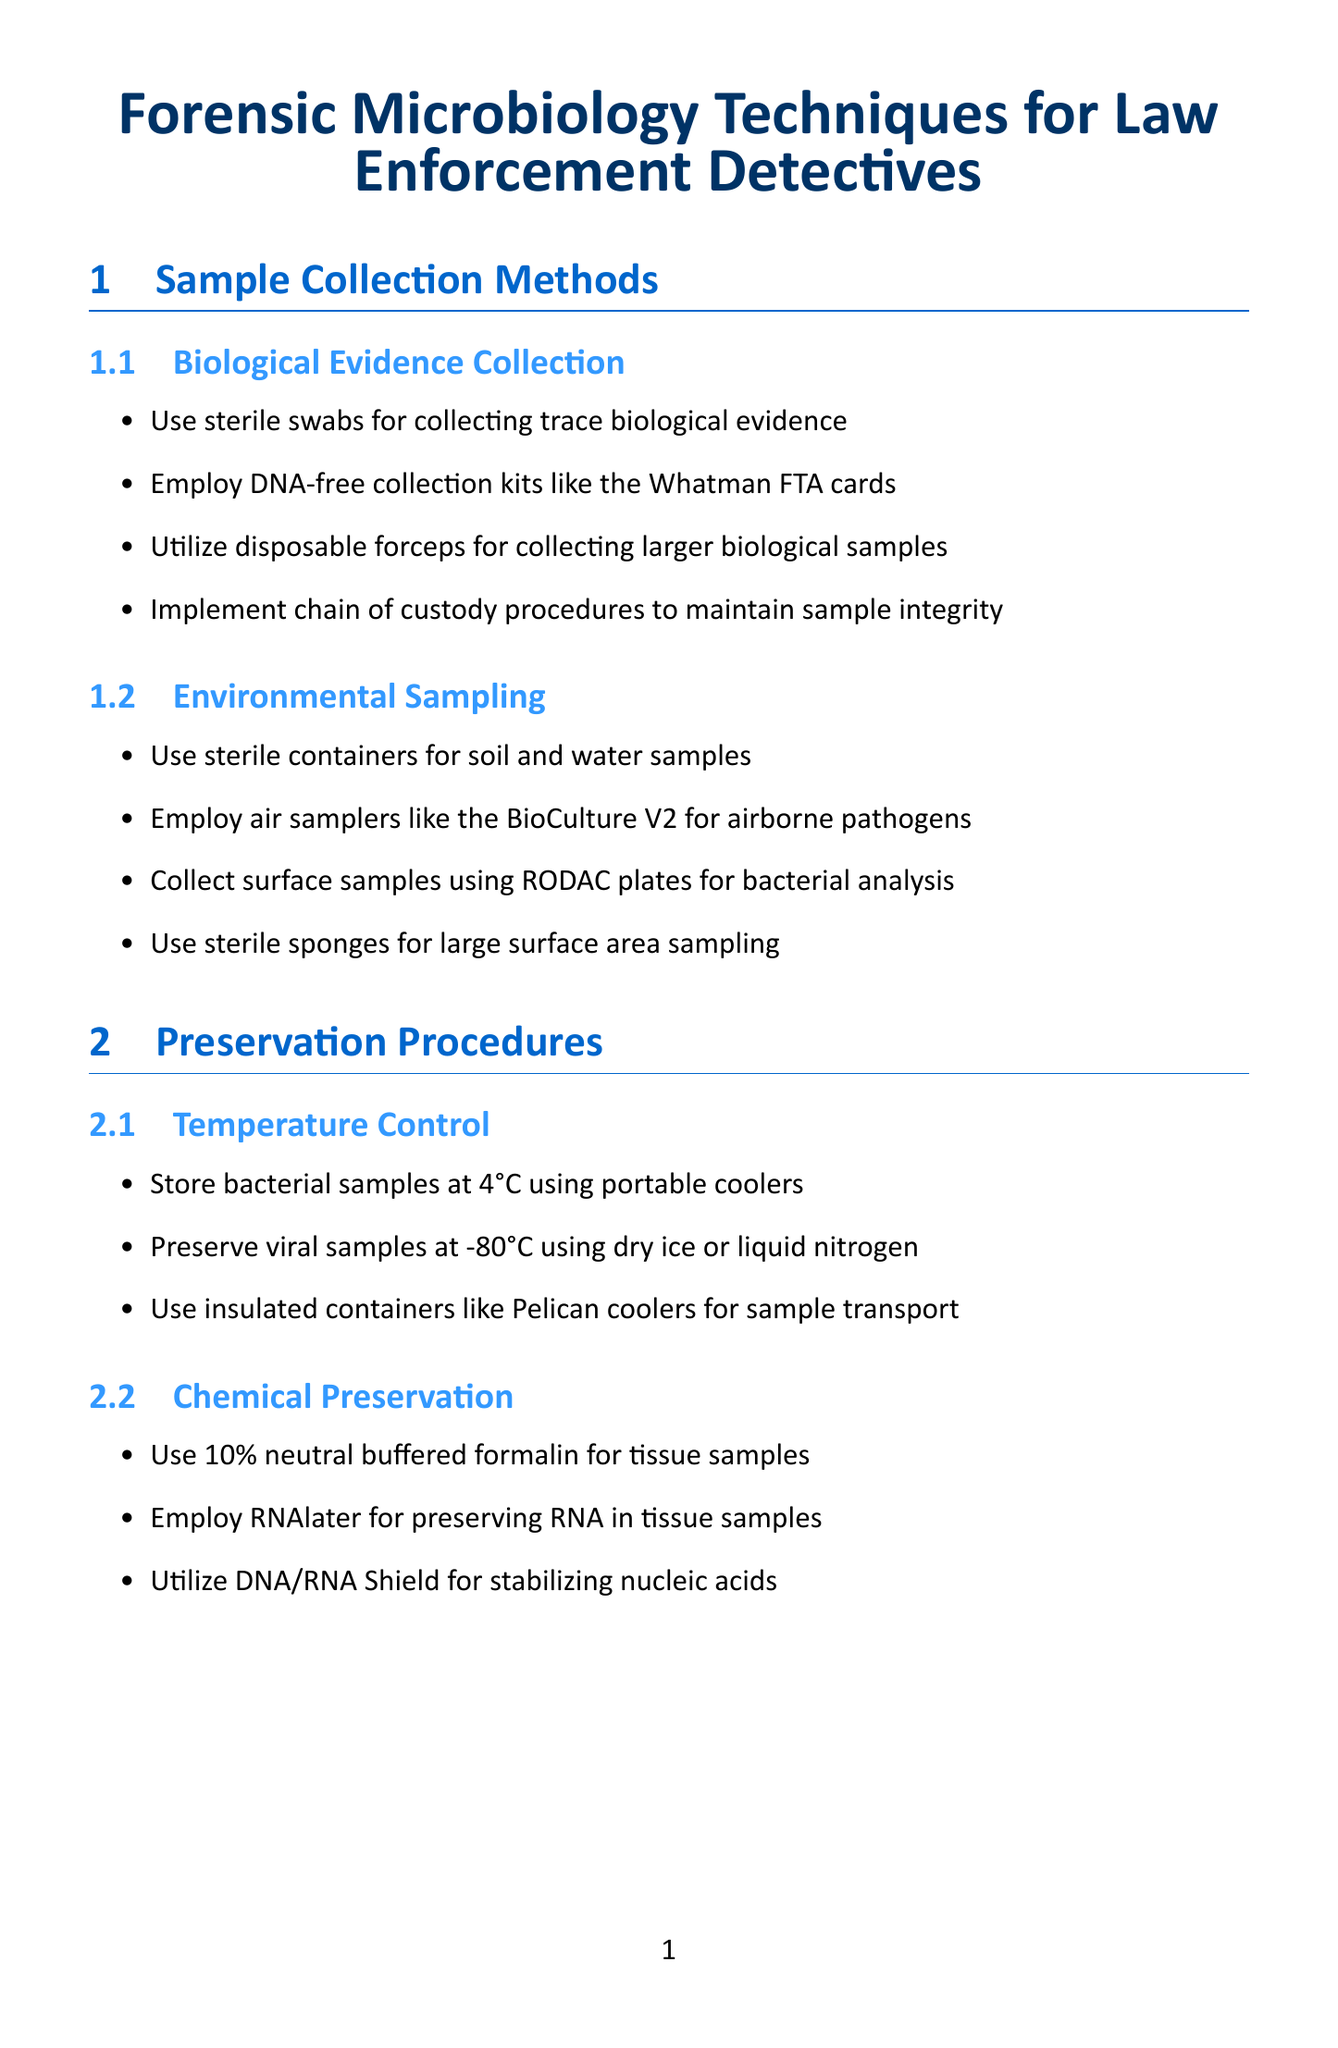what is the title of the document? The title of the document as stated at the beginning is stated in the document header.
Answer: Forensic Microbiology Techniques for Law Enforcement Detectives how should bacterial samples be stored? The storage method for bacterial samples is indicated in the preservation section concerning temperature control.
Answer: at 4°C what is used for collecting surface samples? The document specifies the tools used for surface sampling under environmental sampling methods.
Answer: RODAC plates which system is used for Real-Time PCR? The specific system used for toxin gene detection via Real-Time PCR is listed in the toxin detection section of the analysis workflows.
Answer: Bio-Rad CFX96 system what preservation method is used for RNA? The chemical preservation method for RNA is detailed in the preservation procedures section.
Answer: RNAlater which method is employed for bacterial identification? The document provides a specific technique for rapid bacterial identification in the analysis workflows section.
Answer: MALDI-TOF MS what is the first step in DNA analysis? The document outlines the initial procedure for DNA analysis as indicated in the analysis workflows section.
Answer: Extract DNA using Qiagen DNeasy Blood & Tissue Kit what is the purpose of discussing case details with microbiologists? The reason for reviewing case details falls under consultation with microbiologists in the recommended practices.
Answer: to determine potential pathogens involved which color is used for the section headings? The color assigned to the section headings is mentioned as part of the formatting details in the document.
Answer: RGB(0,102,204) 